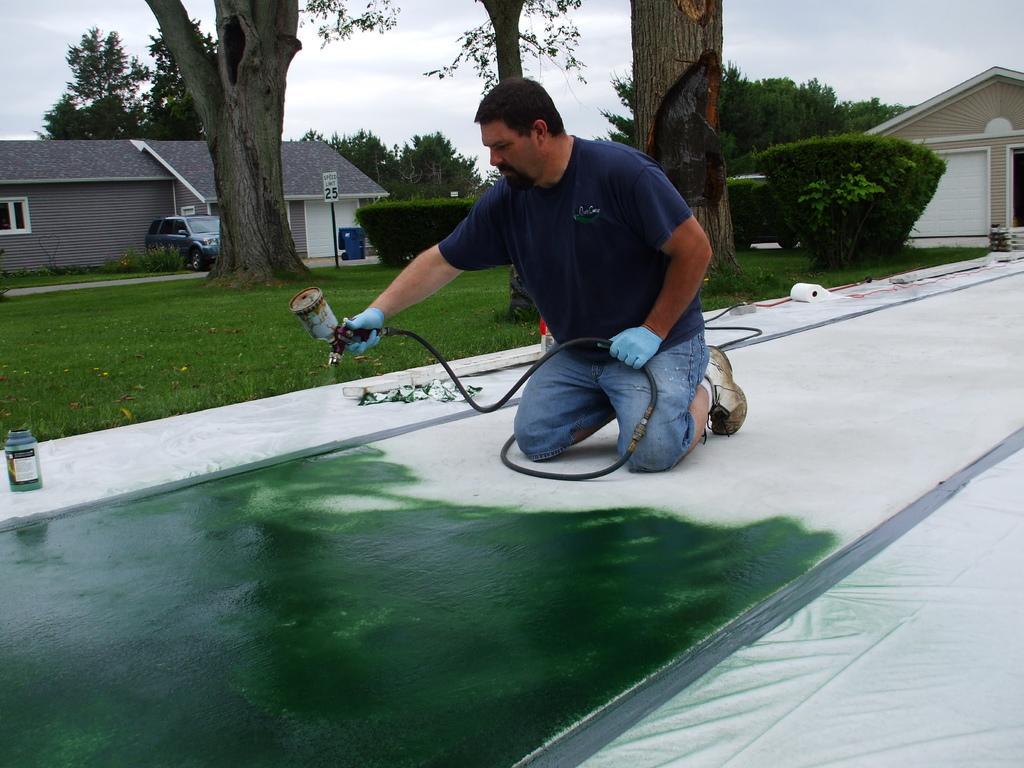Describe this image in one or two sentences. In this image I can see a man is kneeling down on a white surface and holding some objects in hands. In the background I can see houses, a car, the grass, trees and a board. I can also see the sky and some other objects on the ground. 